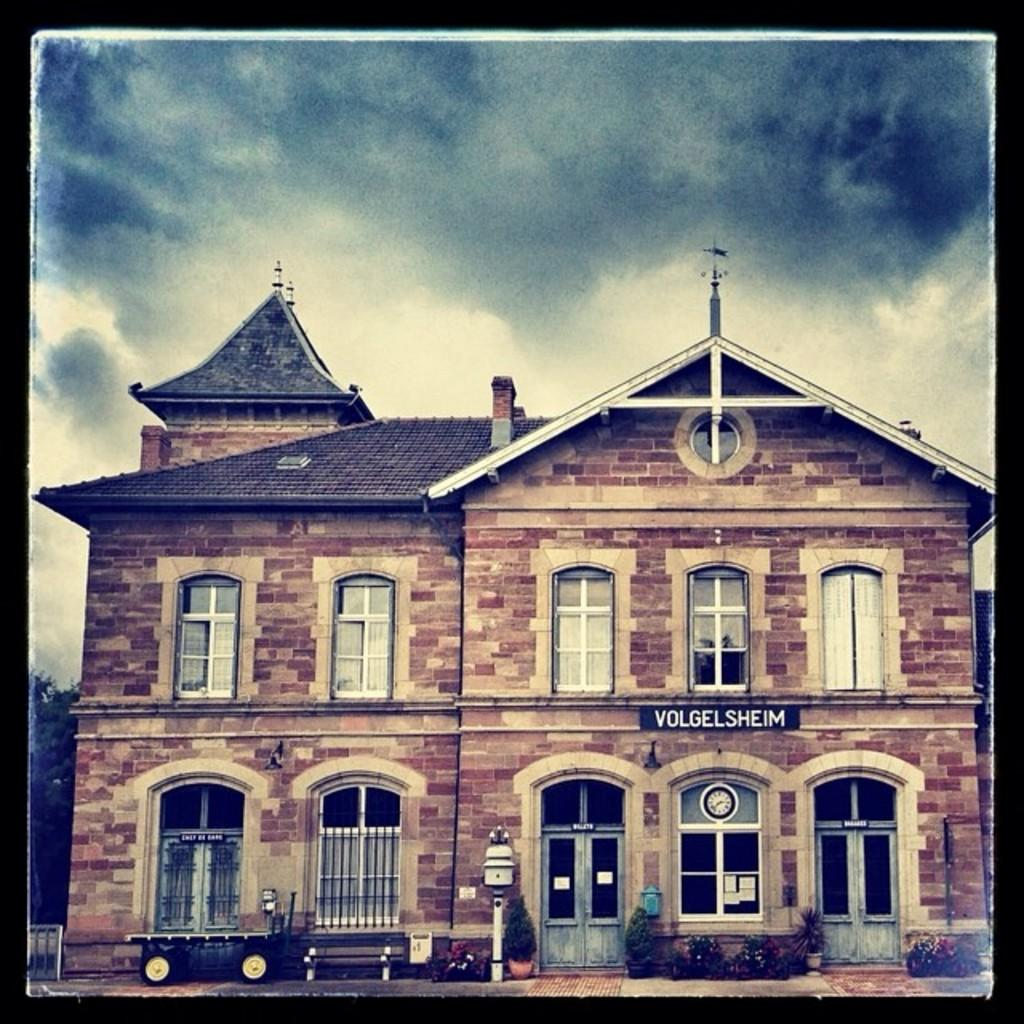What type of structure is present in the image? There is a building in the image. What other elements can be seen in the image? There are plants and a cart visible in the image. What is visible in the sky in the image? Clouds are visible in the image. What type of ice can be seen being served from the cart in the image? There is no ice or ice-related items visible in the image; it features a building, plants, and a cart, but no ice. What type of holiday is being celebrated in the image? There is no indication of a holiday being celebrated in the image. 